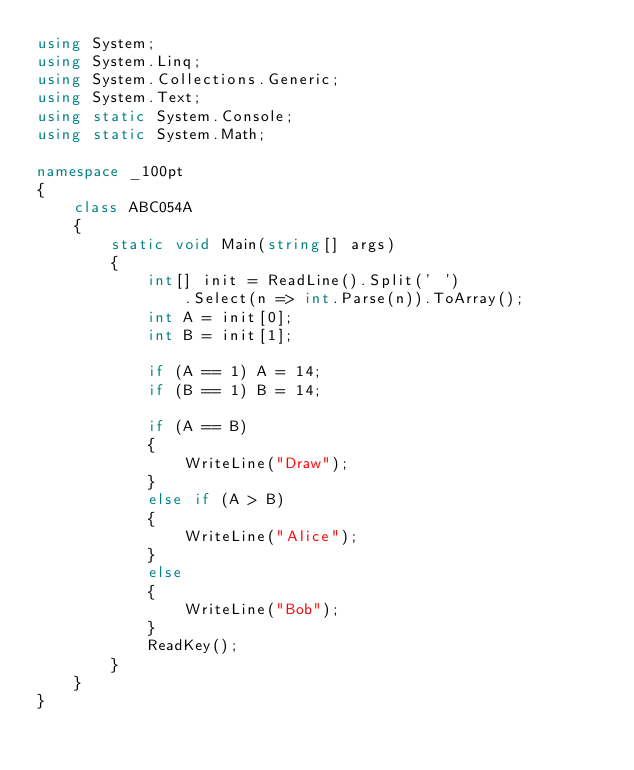<code> <loc_0><loc_0><loc_500><loc_500><_C#_>using System;
using System.Linq;
using System.Collections.Generic;
using System.Text;
using static System.Console;
using static System.Math;

namespace _100pt
{
    class ABC054A
    {
        static void Main(string[] args)
        {
            int[] init = ReadLine().Split(' ')
                .Select(n => int.Parse(n)).ToArray();
            int A = init[0];
            int B = init[1];

            if (A == 1) A = 14;
            if (B == 1) B = 14;

            if (A == B)
            {
                WriteLine("Draw");
            }
            else if (A > B)
            {
                WriteLine("Alice");
            }
            else
            {
                WriteLine("Bob");
            }
            ReadKey();
        }
    }
}
            
</code> 